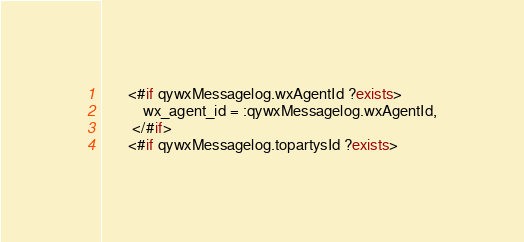Convert code to text. <code><loc_0><loc_0><loc_500><loc_500><_SQL_>	   <#if qywxMessagelog.wxAgentId ?exists>
		   wx_agent_id = :qywxMessagelog.wxAgentId,
		</#if>
	   <#if qywxMessagelog.topartysId ?exists></code> 